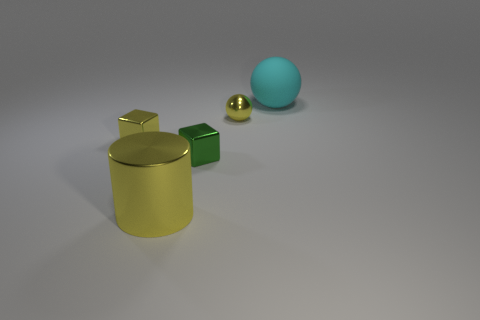Subtract 1 cubes. How many cubes are left? 1 Subtract all cubes. How many objects are left? 3 Add 3 small cubes. How many objects exist? 8 Subtract all tiny blue metal cubes. Subtract all cyan rubber spheres. How many objects are left? 4 Add 3 big metal cylinders. How many big metal cylinders are left? 4 Add 5 big blue metallic balls. How many big blue metallic balls exist? 5 Subtract 0 green balls. How many objects are left? 5 Subtract all blue cylinders. Subtract all green balls. How many cylinders are left? 1 Subtract all yellow cylinders. How many yellow cubes are left? 1 